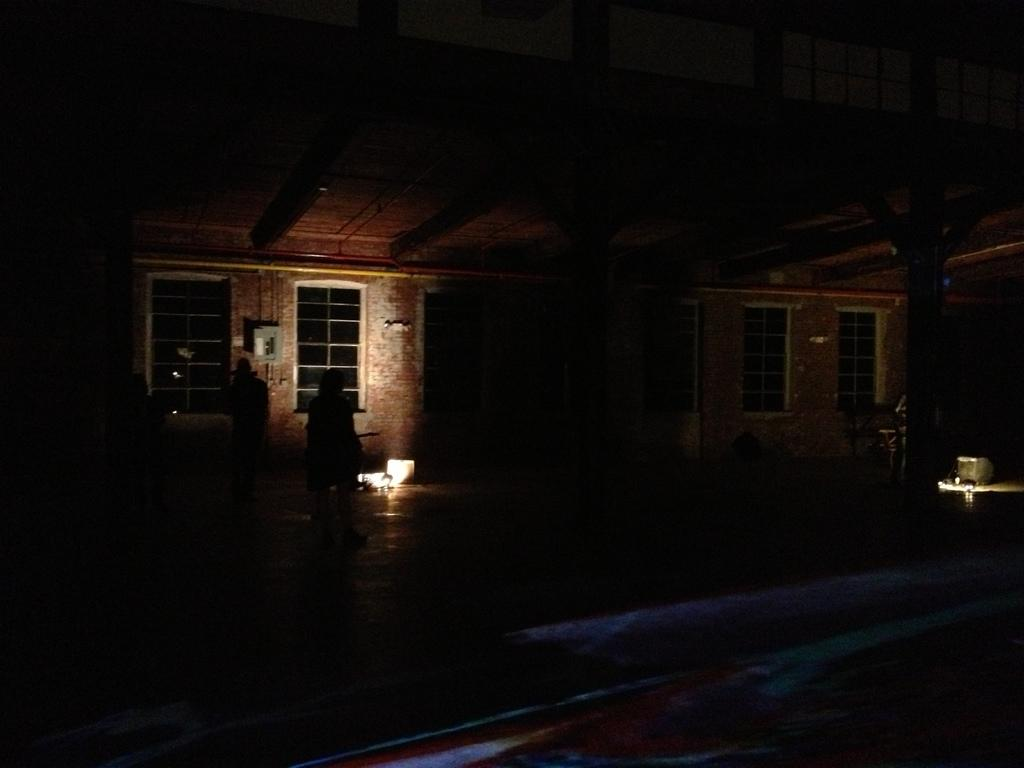What type of structure is visible in the image? The house is in the image. Can you describe the lighting conditions in the image? The house appears to be in a dark setting. Are there any people present in the image? Yes, there are people standing in front of the house. How many girls are standing with the cattle in front of the governor's house in the image? There are no girls, cattle, or governor mentioned in the image. The image only features a house in a dark setting with people standing in front of it. 